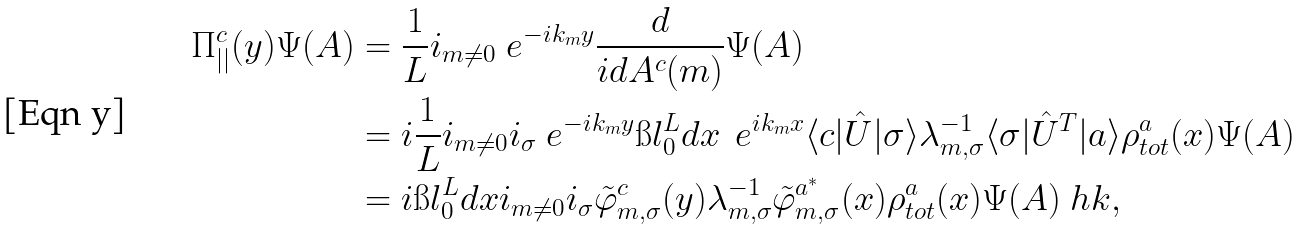<formula> <loc_0><loc_0><loc_500><loc_500>\Pi ^ { c } _ { | | } ( y ) \Psi ( A ) & = \frac { 1 } { L } \sl i _ { m \neq 0 } \ e ^ { - i k _ { m } y } \frac { d } { i d A ^ { c } ( m ) } \Psi ( A ) \\ & = i \frac { 1 } { L } \sl i _ { m \neq 0 } \sl i _ { \sigma } \ e ^ { - i k _ { m } y } \i l ^ { L } _ { 0 } d x \, \ e ^ { i k _ { m } x } \langle c | \hat { U } | \sigma \rangle \lambda ^ { - 1 } _ { m , \sigma } \langle \sigma | \hat { U } ^ { T } | a \rangle \rho ^ { a } _ { t o t } ( x ) \Psi ( A ) \\ & = i \i l ^ { L } _ { 0 } d x \sl i _ { m \neq 0 } \sl i _ { \sigma } \tilde { \varphi } ^ { c } _ { m , \sigma } ( y ) \lambda ^ { - 1 } _ { m , \sigma } \tilde { \varphi } ^ { a ^ { * } } _ { m , \sigma } ( x ) \rho ^ { a } _ { t o t } ( x ) \Psi ( A ) \ h k ,</formula> 